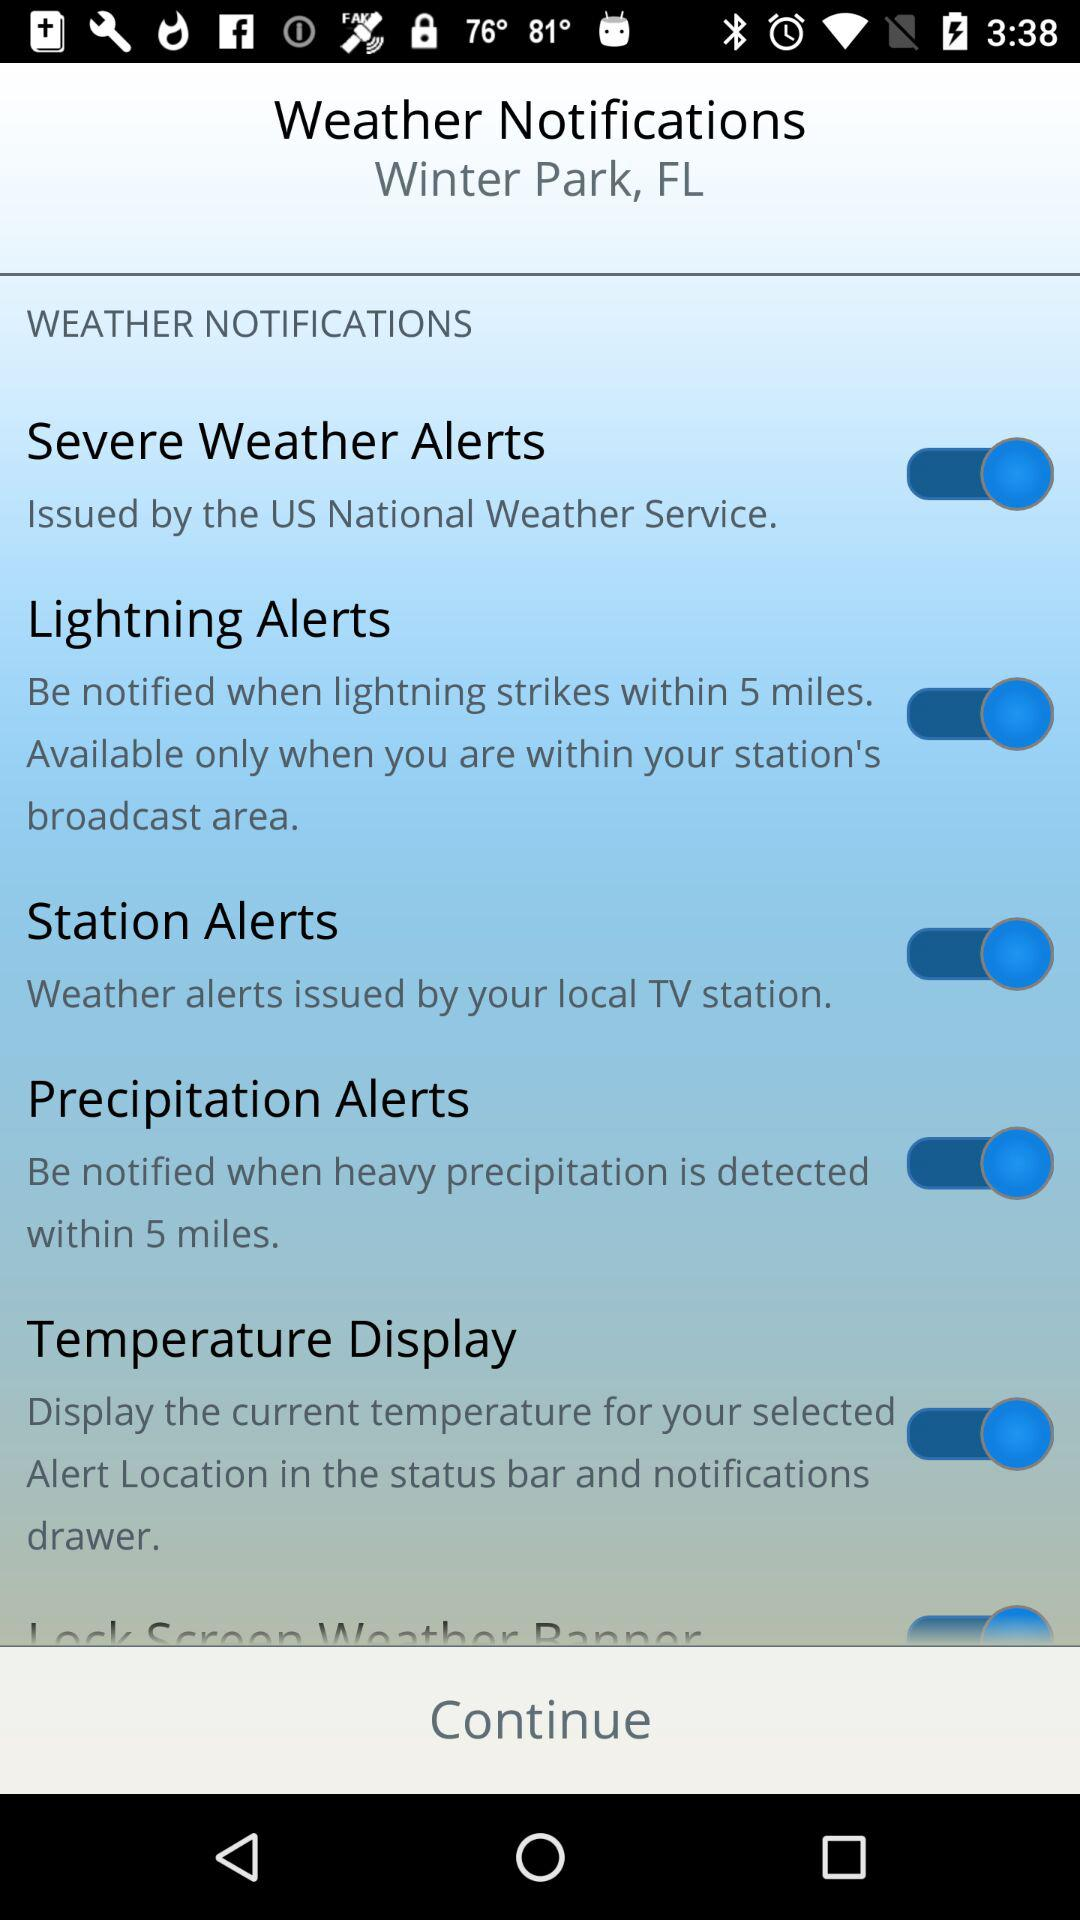When were the most recent weather notifications posted?
When the provided information is insufficient, respond with <no answer>. <no answer> 